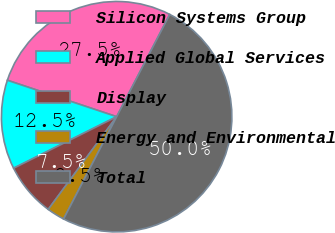Convert chart to OTSL. <chart><loc_0><loc_0><loc_500><loc_500><pie_chart><fcel>Silicon Systems Group<fcel>Applied Global Services<fcel>Display<fcel>Energy and Environmental<fcel>Total<nl><fcel>27.5%<fcel>12.5%<fcel>7.5%<fcel>2.5%<fcel>50.0%<nl></chart> 